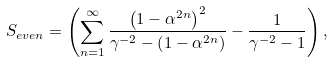Convert formula to latex. <formula><loc_0><loc_0><loc_500><loc_500>& S _ { e v e n } = \left ( \sum _ { n = 1 } ^ { \infty } \frac { \left ( 1 - \alpha ^ { 2 n } \right ) ^ { 2 } } { \gamma ^ { - 2 } - \left ( 1 - \alpha ^ { 2 n } \right ) } - \frac { 1 } { \gamma ^ { - 2 } - 1 } \right ) ,</formula> 